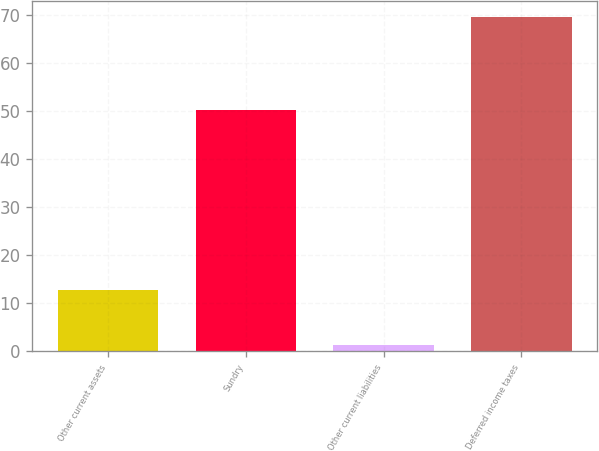<chart> <loc_0><loc_0><loc_500><loc_500><bar_chart><fcel>Other current assets<fcel>Sundry<fcel>Other current liabilities<fcel>Deferred income taxes<nl><fcel>12.8<fcel>50.2<fcel>1.3<fcel>69.6<nl></chart> 